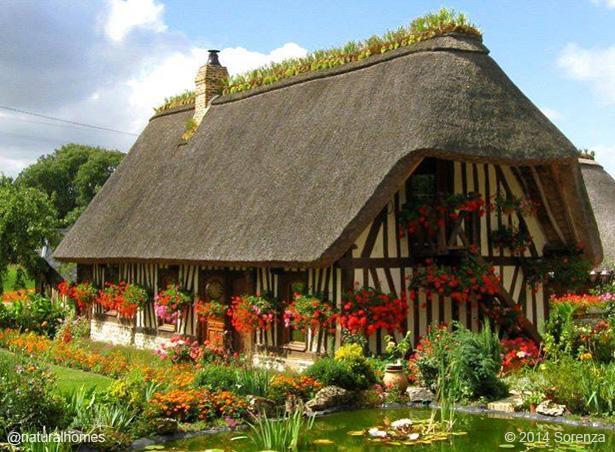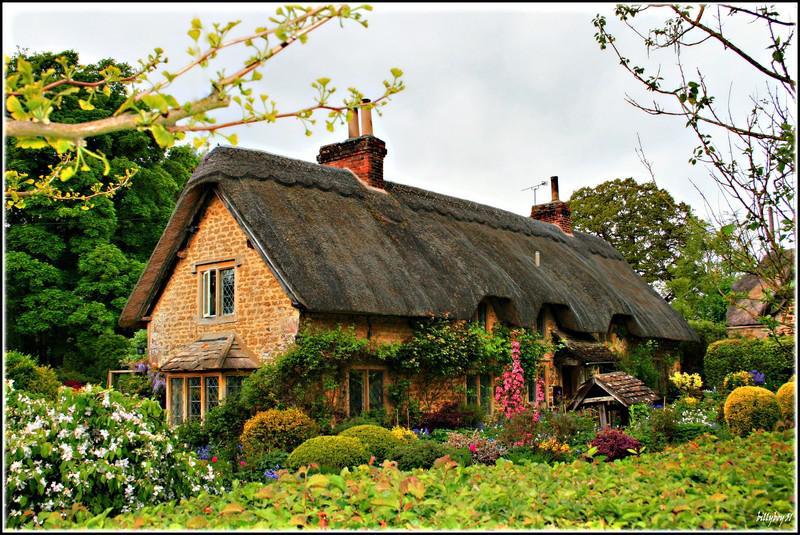The first image is the image on the left, the second image is the image on the right. For the images displayed, is the sentence "The right image contains a tree house." factually correct? Answer yes or no. No. The first image is the image on the left, the second image is the image on the right. Considering the images on both sides, is "A house with a thatched roof is up on stilts." valid? Answer yes or no. No. 